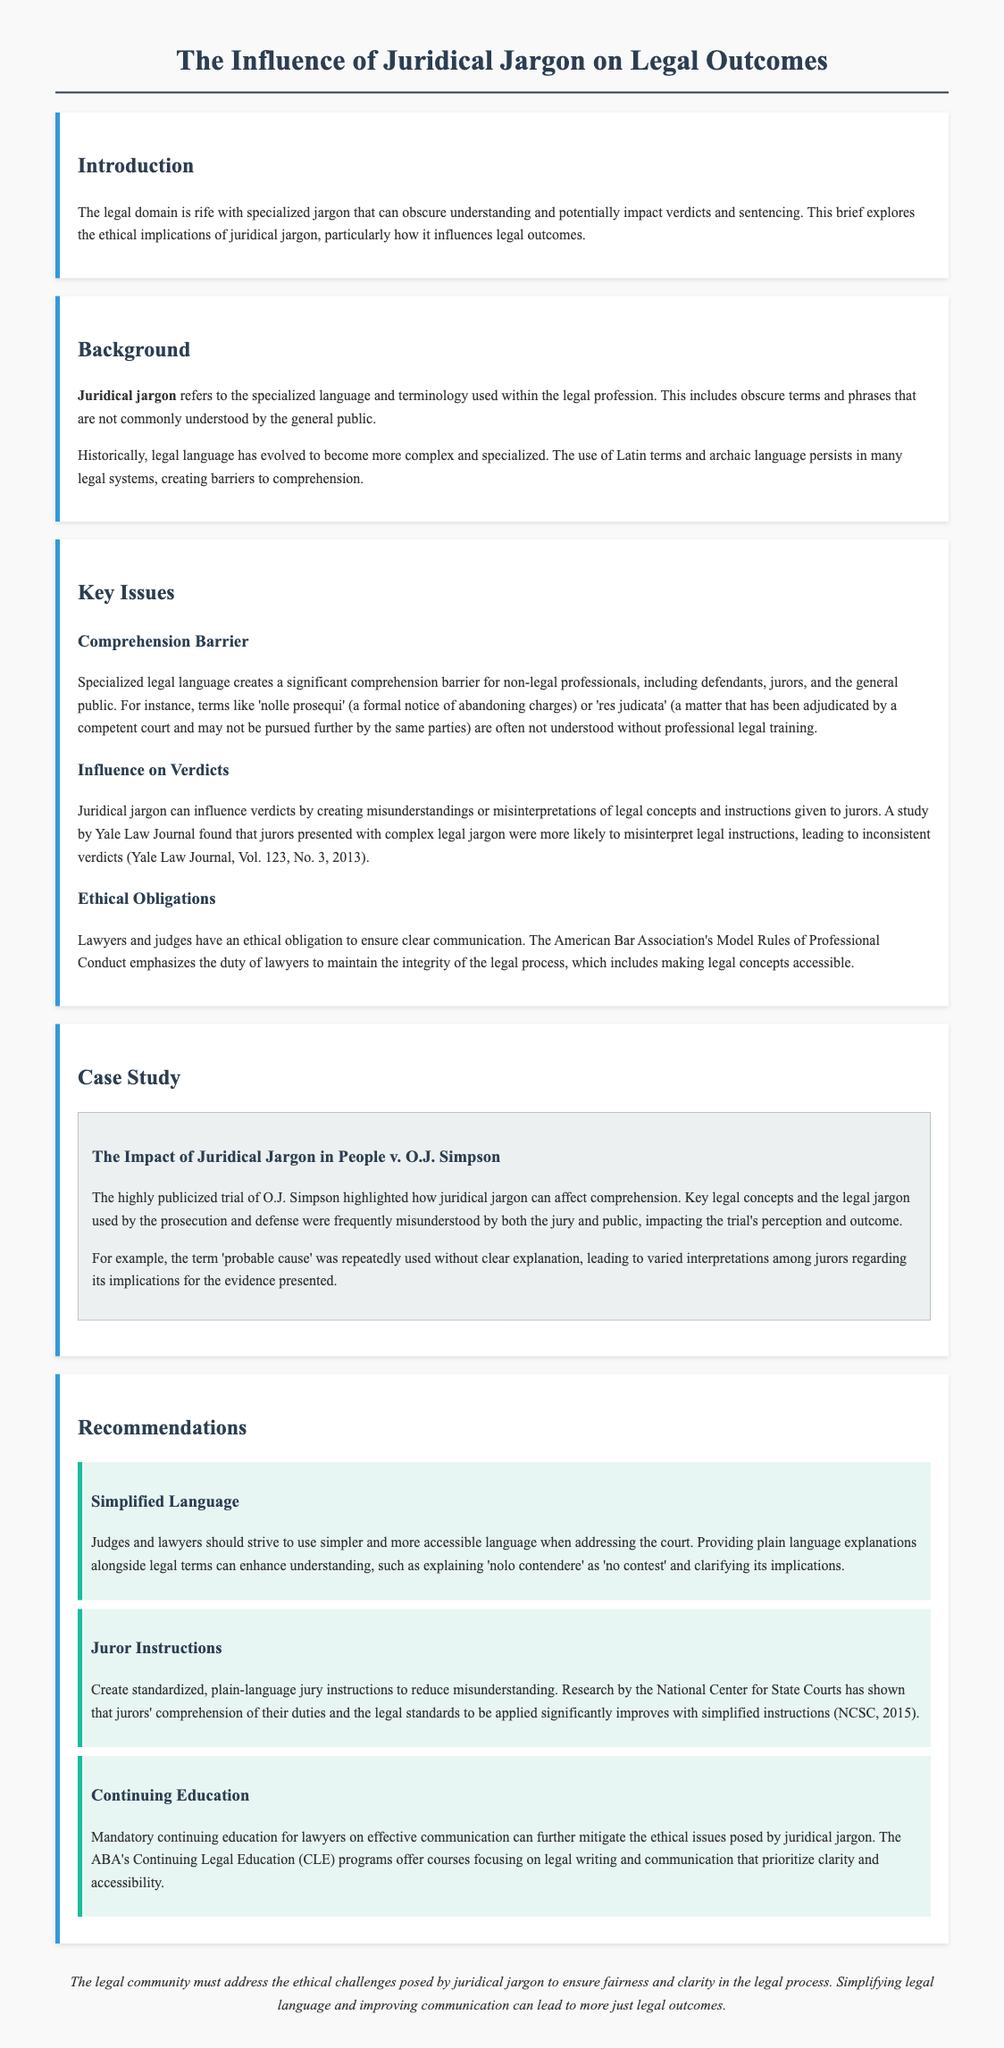What is the title of the document? The title is mentioned at the top of the document and describes the main focus of the legal brief.
Answer: The Influence of Juridical Jargon on Legal Outcomes What year did the Yale Law Journal study referenced in the document take place? The document provides the volume and issue number of the Yale Law Journal which indicates when the study was conducted.
Answer: 2013 What is a term that represents a comprehension barrier for non-legal professionals according to the document? The document lists specific terms that exemplify the jargon creating comprehension barriers in the legal system.
Answer: Nolle prosequi Who has an ethical obligation to ensure clear communication as per the document? The document outlines the responsibilities of specific legal professionals regarding communication clarity.
Answer: Lawyers and judges What is one recommendation for improving juror instructions stated in the document? The document suggests specific measures to improve juror understanding, particularly to reduce misunderstandings.
Answer: Standardized, plain-language jury instructions In what case study is juristic jargon's influence highlighted? The document mentions a specific case that serves as an example of the impact of juridical jargon.
Answer: People v. O.J. Simpson What is the main ethical challenge posed by juridical jargon highlighted in the brief? The document discusses the overarching ethical dilemma regarding comprehension and communication in legal outcomes.
Answer: Comprehension barriers What is one consequence of using complex legal jargon in verdicts? The document explains how jurors can misinterpret legal concepts, impacting the decisions they make.
Answer: Inconsistent verdicts 